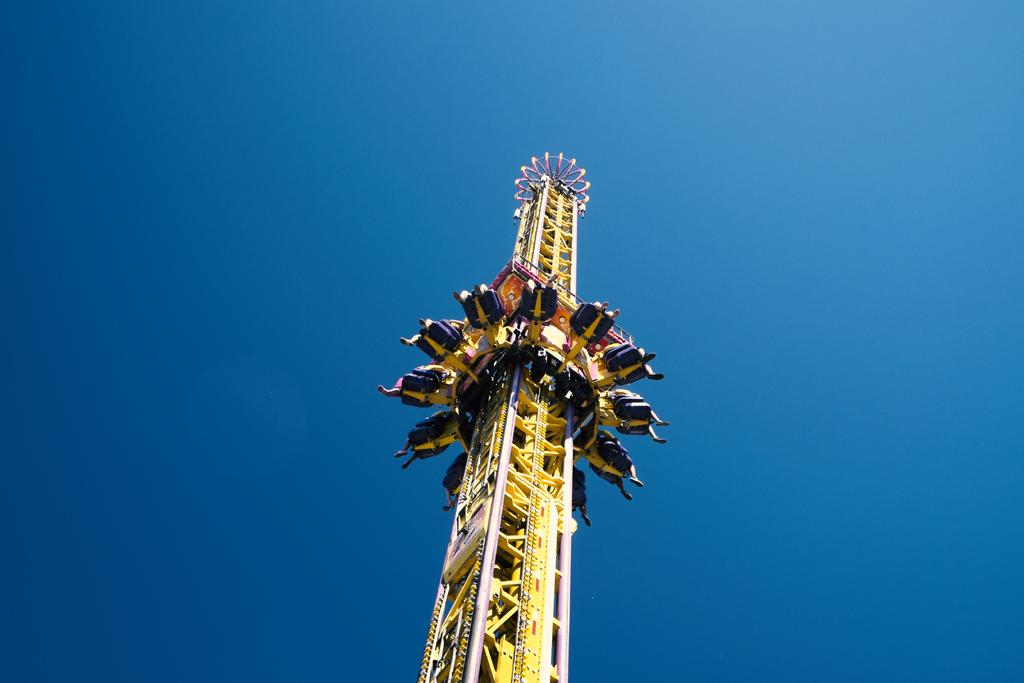What type of amusement park ride is in the image? There is a yellow amusement park ride in the image. Are there any people on the ride? Yes, there are people sitting on the ride. What color is the background of the image? The background of the image appears to be blue. What type of silk is being used to decorate the amusement park ride in the image? There is no silk present in the image, and the amusement park ride is not being decorated with any fabric. 